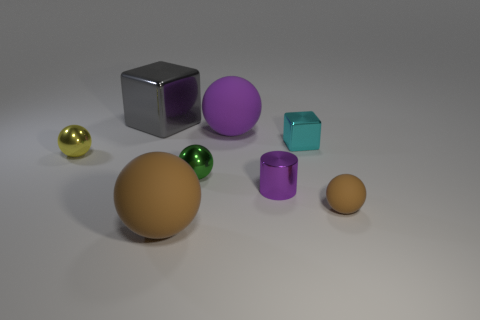What shape is the object that is the same color as the small rubber sphere?
Provide a short and direct response. Sphere. The other object that is the same color as the tiny matte object is what size?
Offer a terse response. Large. There is a large thing that is the same color as the small rubber sphere; what material is it?
Provide a succinct answer. Rubber. What number of cylinders are the same material as the green thing?
Your response must be concise. 1. What is the size of the purple thing that is the same shape as the small green metallic object?
Your answer should be very brief. Large. Is the number of cyan metallic objects the same as the number of large green cylinders?
Provide a short and direct response. No. Is the size of the cyan shiny block the same as the gray thing?
Ensure brevity in your answer.  No. There is a matte object on the left side of the rubber object behind the tiny metallic object to the left of the large shiny block; what shape is it?
Ensure brevity in your answer.  Sphere. There is a tiny rubber thing that is the same shape as the big brown thing; what color is it?
Your answer should be very brief. Brown. There is a shiny thing that is behind the tiny yellow shiny thing and in front of the gray thing; what is its size?
Keep it short and to the point. Small. 